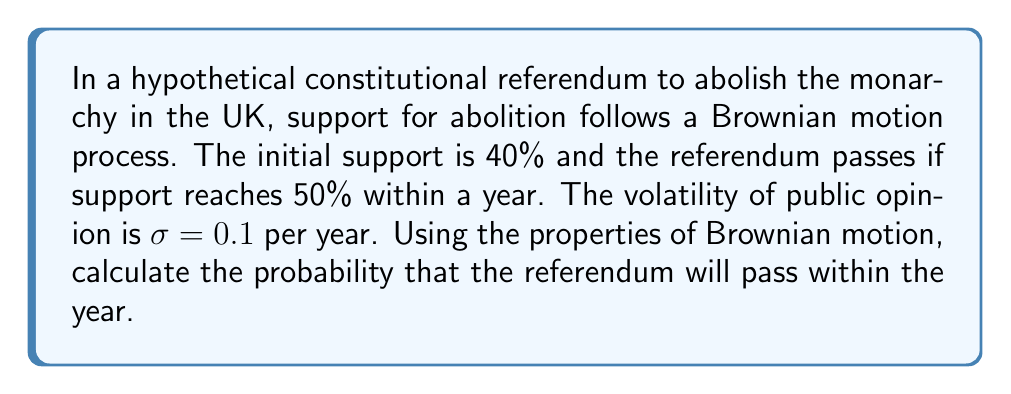What is the answer to this math problem? Let's approach this step-by-step:

1) We can model this situation using a Brownian motion process with drift. The support percentage $S_t$ at time $t$ follows:

   $$dS_t = \mu dt + \sigma dW_t$$

   where $\mu$ is the drift, $\sigma = 0.1$ is the volatility, and $W_t$ is a Wiener process.

2) In this case, we're interested in the probability of hitting a barrier (50%) before a certain time (1 year). This is known as the first passage time problem.

3) For a Brownian motion without drift ($\mu = 0$), the probability of hitting a barrier $b$ starting from $a$ within time $T$ is given by:

   $$P(T) = 1 - \text{erf}\left(\frac{b-a}{\sigma\sqrt{2T}}\right)$$

   where erf is the error function.

4) In our case:
   $a = 40$ (initial support)
   $b = 50$ (target support)
   $T = 1$ (year)
   $\sigma = 0.1$

5) Plugging these values into the formula:

   $$P(1) = 1 - \text{erf}\left(\frac{50-40}{0.1\sqrt{2(1)}}\right) = 1 - \text{erf}(70.71)$$

6) The error function for such a large value is very close to 1, so:

   $$P(1) \approx 1 - 1 = 0$$

7) This means the probability is extremely small, effectively zero for practical purposes.
Answer: $\approx 0$ 